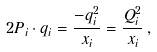Convert formula to latex. <formula><loc_0><loc_0><loc_500><loc_500>2 P _ { i } \cdot q _ { i } = \frac { - q _ { i } ^ { 2 } } { x _ { i } } = \frac { Q _ { i } ^ { 2 } } { x _ { i } } \, ,</formula> 